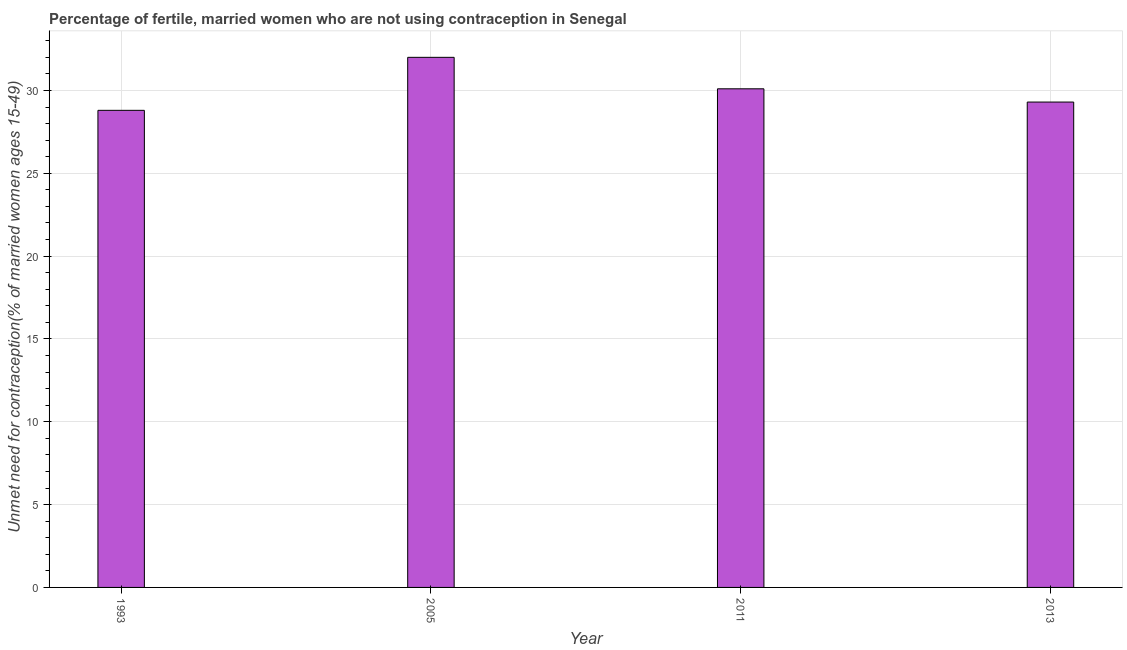Does the graph contain any zero values?
Ensure brevity in your answer.  No. What is the title of the graph?
Provide a succinct answer. Percentage of fertile, married women who are not using contraception in Senegal. What is the label or title of the Y-axis?
Your answer should be compact.  Unmet need for contraception(% of married women ages 15-49). What is the number of married women who are not using contraception in 1993?
Your answer should be very brief. 28.8. Across all years, what is the minimum number of married women who are not using contraception?
Keep it short and to the point. 28.8. In which year was the number of married women who are not using contraception maximum?
Provide a succinct answer. 2005. In which year was the number of married women who are not using contraception minimum?
Give a very brief answer. 1993. What is the sum of the number of married women who are not using contraception?
Keep it short and to the point. 120.2. What is the difference between the number of married women who are not using contraception in 1993 and 2005?
Offer a very short reply. -3.2. What is the average number of married women who are not using contraception per year?
Offer a terse response. 30.05. What is the median number of married women who are not using contraception?
Provide a succinct answer. 29.7. Do a majority of the years between 2011 and 2013 (inclusive) have number of married women who are not using contraception greater than 14 %?
Your answer should be very brief. Yes. What is the ratio of the number of married women who are not using contraception in 2005 to that in 2011?
Make the answer very short. 1.06. Is the number of married women who are not using contraception in 1993 less than that in 2005?
Offer a very short reply. Yes. Is the difference between the number of married women who are not using contraception in 2005 and 2011 greater than the difference between any two years?
Give a very brief answer. No. What is the difference between the highest and the second highest number of married women who are not using contraception?
Make the answer very short. 1.9. What is the difference between the highest and the lowest number of married women who are not using contraception?
Keep it short and to the point. 3.2. Are all the bars in the graph horizontal?
Give a very brief answer. No. What is the difference between two consecutive major ticks on the Y-axis?
Your answer should be compact. 5. Are the values on the major ticks of Y-axis written in scientific E-notation?
Your answer should be very brief. No. What is the  Unmet need for contraception(% of married women ages 15-49) of 1993?
Offer a terse response. 28.8. What is the  Unmet need for contraception(% of married women ages 15-49) of 2011?
Your response must be concise. 30.1. What is the  Unmet need for contraception(% of married women ages 15-49) of 2013?
Ensure brevity in your answer.  29.3. What is the difference between the  Unmet need for contraception(% of married women ages 15-49) in 1993 and 2005?
Provide a succinct answer. -3.2. What is the difference between the  Unmet need for contraception(% of married women ages 15-49) in 1993 and 2013?
Keep it short and to the point. -0.5. What is the difference between the  Unmet need for contraception(% of married women ages 15-49) in 2005 and 2013?
Your answer should be compact. 2.7. What is the difference between the  Unmet need for contraception(% of married women ages 15-49) in 2011 and 2013?
Offer a very short reply. 0.8. What is the ratio of the  Unmet need for contraception(% of married women ages 15-49) in 1993 to that in 2005?
Your answer should be very brief. 0.9. What is the ratio of the  Unmet need for contraception(% of married women ages 15-49) in 1993 to that in 2013?
Your answer should be compact. 0.98. What is the ratio of the  Unmet need for contraception(% of married women ages 15-49) in 2005 to that in 2011?
Offer a terse response. 1.06. What is the ratio of the  Unmet need for contraception(% of married women ages 15-49) in 2005 to that in 2013?
Your answer should be very brief. 1.09. What is the ratio of the  Unmet need for contraception(% of married women ages 15-49) in 2011 to that in 2013?
Your answer should be compact. 1.03. 